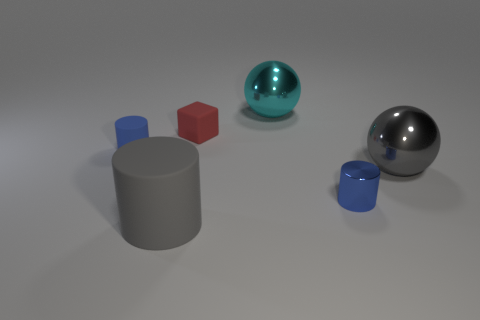How many other small rubber objects are the same shape as the blue rubber object?
Provide a succinct answer. 0. What number of red objects are small cylinders or metallic objects?
Ensure brevity in your answer.  0. There is a red rubber thing behind the object that is right of the blue metal cylinder; what is its size?
Make the answer very short. Small. There is a gray thing that is the same shape as the cyan object; what is it made of?
Your answer should be compact. Metal. How many gray metal objects have the same size as the metal cylinder?
Provide a short and direct response. 0. Is the blue metallic object the same size as the blue rubber thing?
Offer a very short reply. Yes. There is a thing that is both behind the big gray matte cylinder and in front of the big gray sphere; what is its size?
Ensure brevity in your answer.  Small. Are there more balls that are in front of the tiny red matte cube than blue things that are behind the blue rubber cylinder?
Your answer should be very brief. Yes. There is a metallic object that is the same shape as the tiny blue matte object; what is its color?
Provide a short and direct response. Blue. There is a small cylinder that is right of the red cube; is its color the same as the small matte cylinder?
Provide a short and direct response. Yes. 